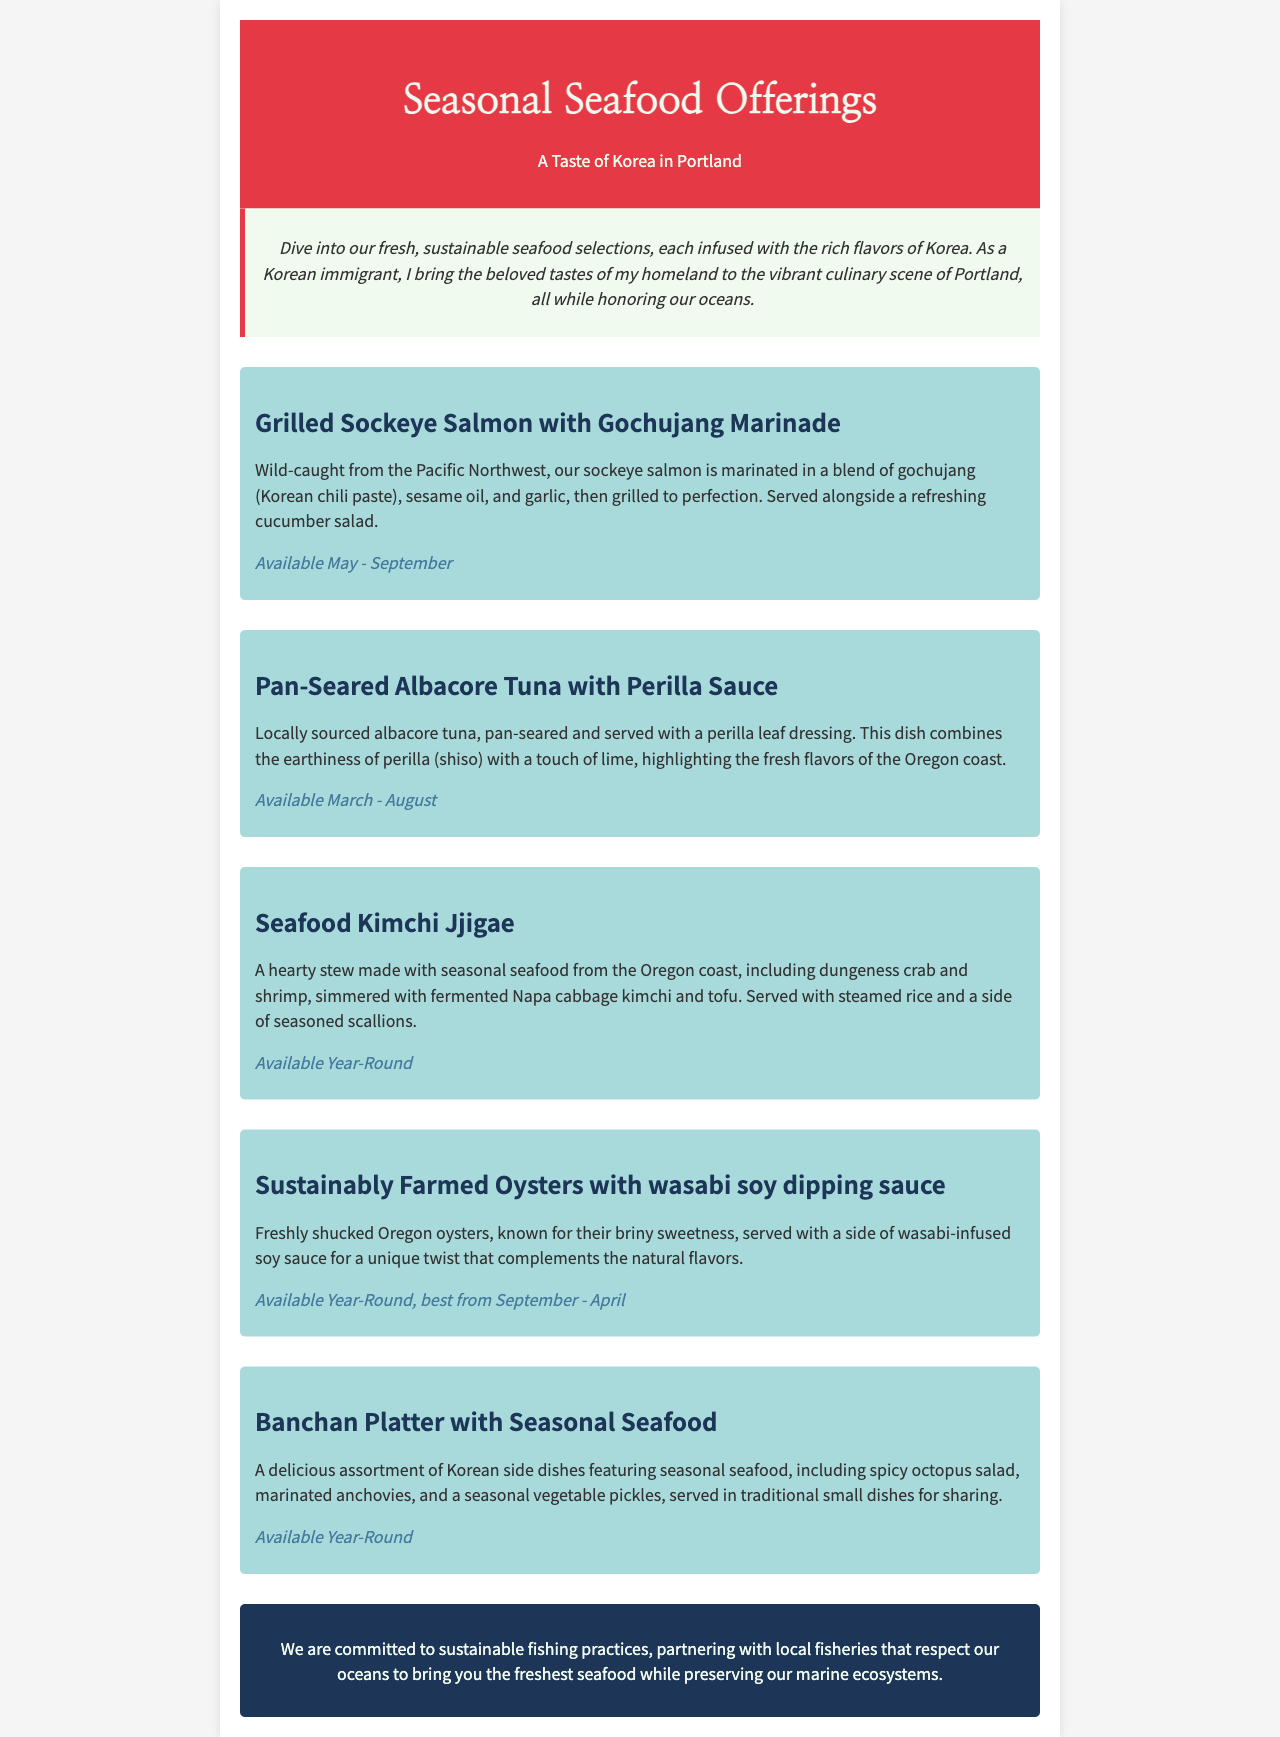What is the name of the grilled salmon dish? The grilled salmon dish is specifically mentioned as "Grilled Sockeye Salmon with Gochujang Marinade."
Answer: Grilled Sockeye Salmon with Gochujang Marinade What is the seasonality for the pan-seared albacore tuna? The document states that the pan-seared albacore tuna is available from March to August.
Answer: March - August Which seafood item is served with wasabi soy dipping sauce? The document indicates that the sustainably farmed oysters are served with wasabi soy dipping sauce.
Answer: Sustainably Farmed Oysters How many seafood dishes are available year-round? The document lists four dishes that are available year-round: Seafood Kimchi Jjigae, sustainably farmed oysters, Banchan Platter, and one more.
Answer: 4 What is the main seasoning in the grilled sockeye salmon marinade? The document identifies gochujang as the main seasoning in the grilled sockeye salmon marinade.
Answer: Gochujang What is the purpose of the banchan platter? The document describes the banchan platter as an assortment of Korean side dishes featuring seasonal seafood for sharing.
Answer: Sharing How does the restaurant ensure sustainability? The document explains that the restaurant partners with local fisheries that respect the oceans.
Answer: Partnering with local fisheries What dish features dungeness crab? The Seafood Kimchi Jjigae is the dish that features dungeness crab according to the document.
Answer: Seafood Kimchi Jjigae 